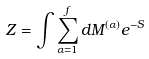Convert formula to latex. <formula><loc_0><loc_0><loc_500><loc_500>Z = \int \sum _ { \alpha = 1 } ^ { f } d M ^ { ( \alpha ) } e ^ { - S }</formula> 